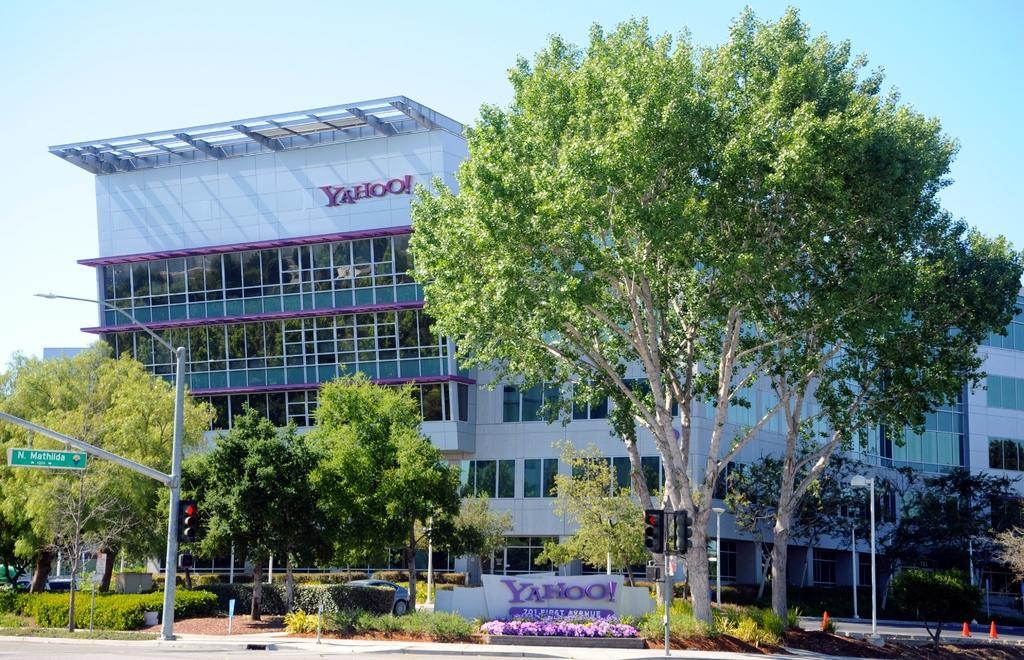Please provide a concise description of this image. In this image we can see a building with glasses. There are trees. There is a pole. There are plants. To the right side of the image there are safety cones. At the top of the image there is sky. 